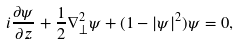<formula> <loc_0><loc_0><loc_500><loc_500>i \frac { \partial \psi } { \partial z } + \frac { 1 } { 2 } \nabla _ { \perp } ^ { 2 } \psi + ( 1 - | \psi | ^ { 2 } ) \psi = 0 ,</formula> 